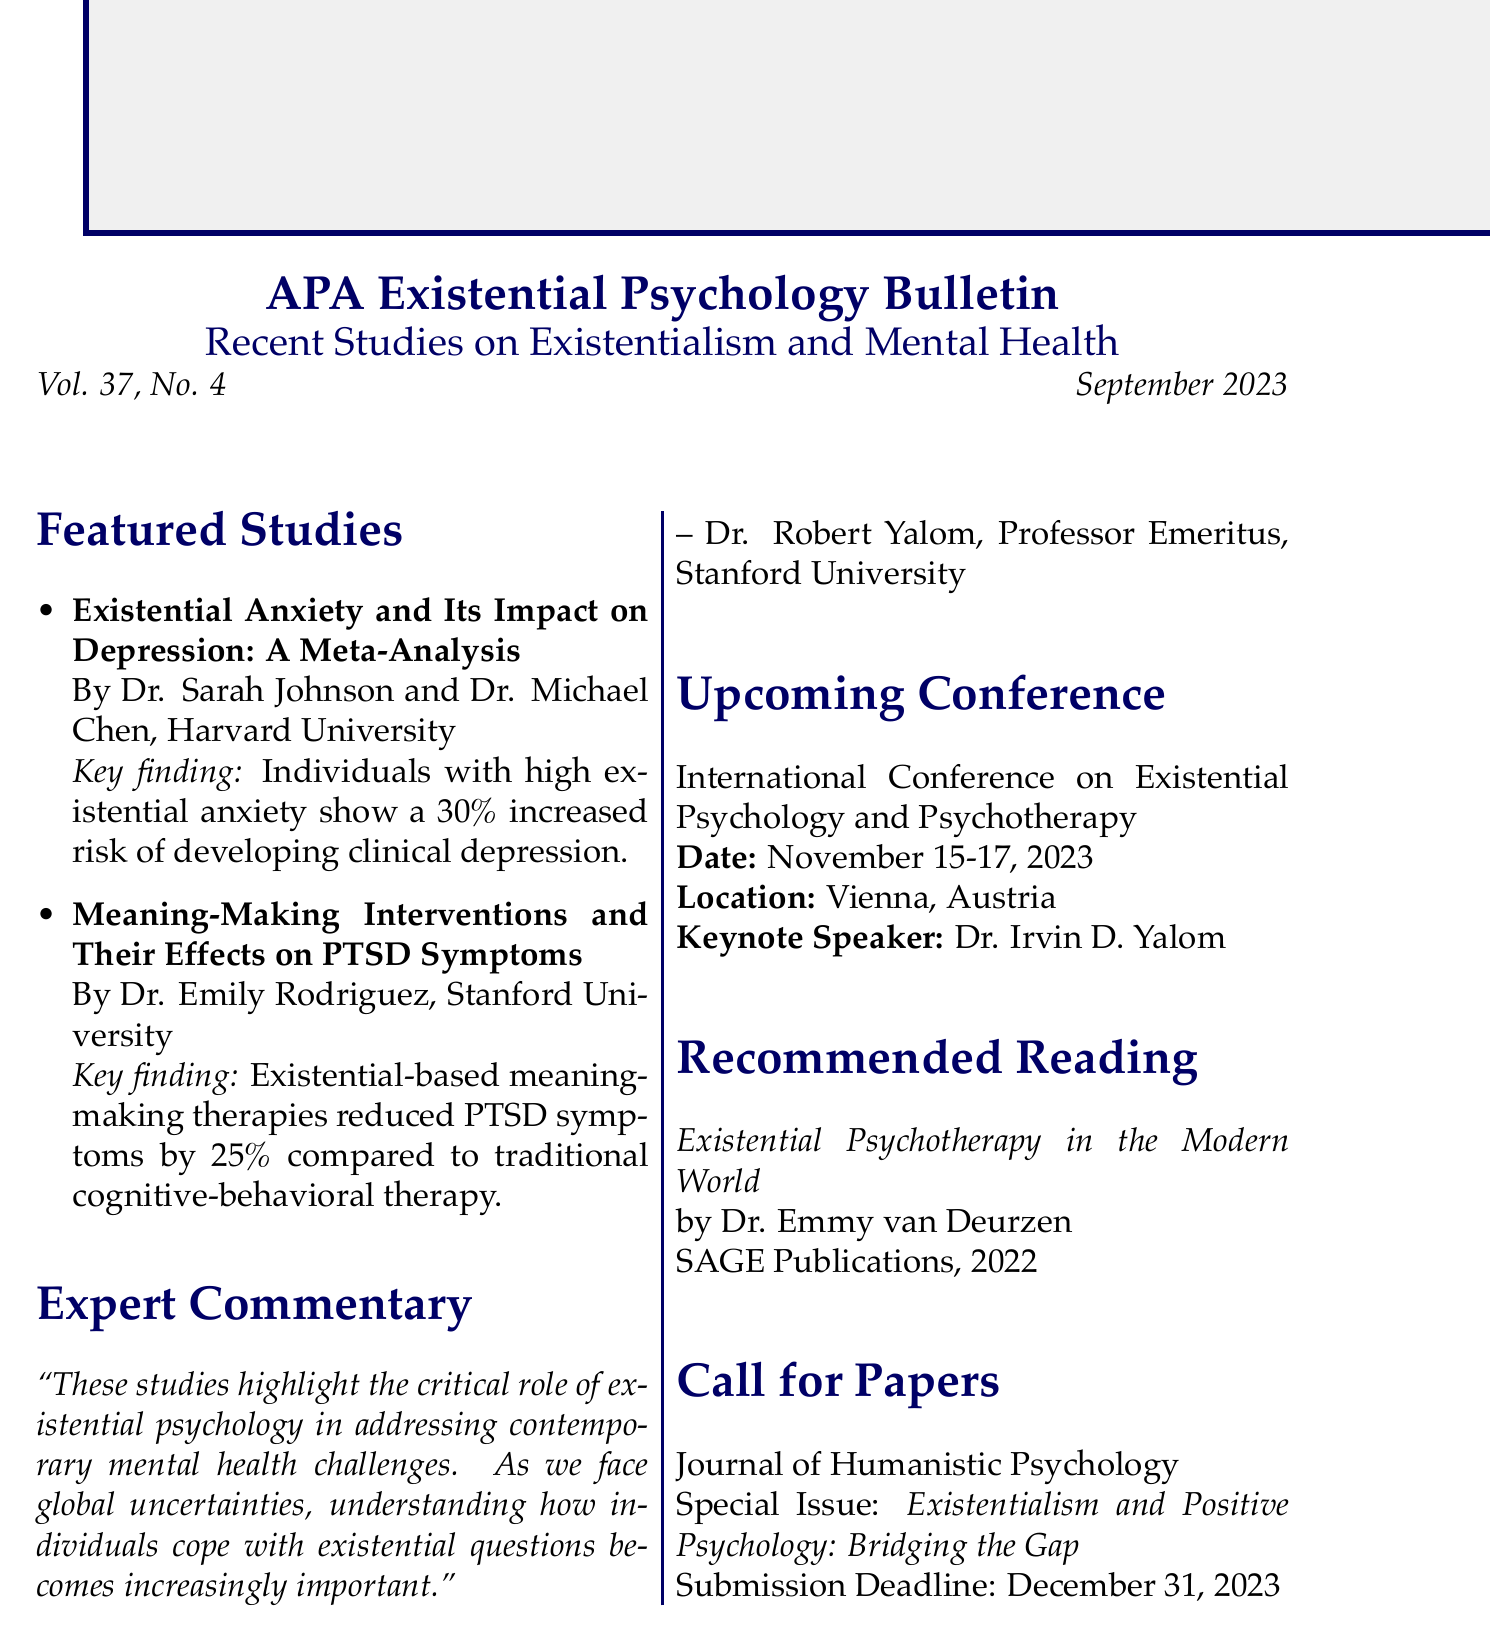what is the title of the newsletter? The title of the newsletter is stated at the beginning of the document.
Answer: APA Existential Psychology Bulletin: Recent Studies on Existentialism and Mental Health who are the authors of the study on existential anxiety? The document lists the authors for the featured study on existential anxiety.
Answer: Dr. Sarah Johnson and Dr. Michael Chen what is the publication date of this issue? The publication date is mentioned prominently in the document.
Answer: September 2023 how much did meaning-making therapies reduce PTSD symptoms by? This information is found in the key findings of the relevant study.
Answer: 25% who is the keynote speaker for the upcoming conference? The keynote speaker is mentioned in the section about the upcoming conference.
Answer: Dr. Irvin D. Yalom what is the theme of the special issue in the call for papers? The theme is explicitly stated in the call for papers section of the document.
Answer: Existentialism and Positive Psychology: Bridging the Gap what is the name of the recommended reading book? The recommended reading section provides the title of the book.
Answer: Existential Psychotherapy in the Modern World how many studies are featured in this newsletter? By counting the items listed under featured studies, we determine the total number.
Answer: 2 